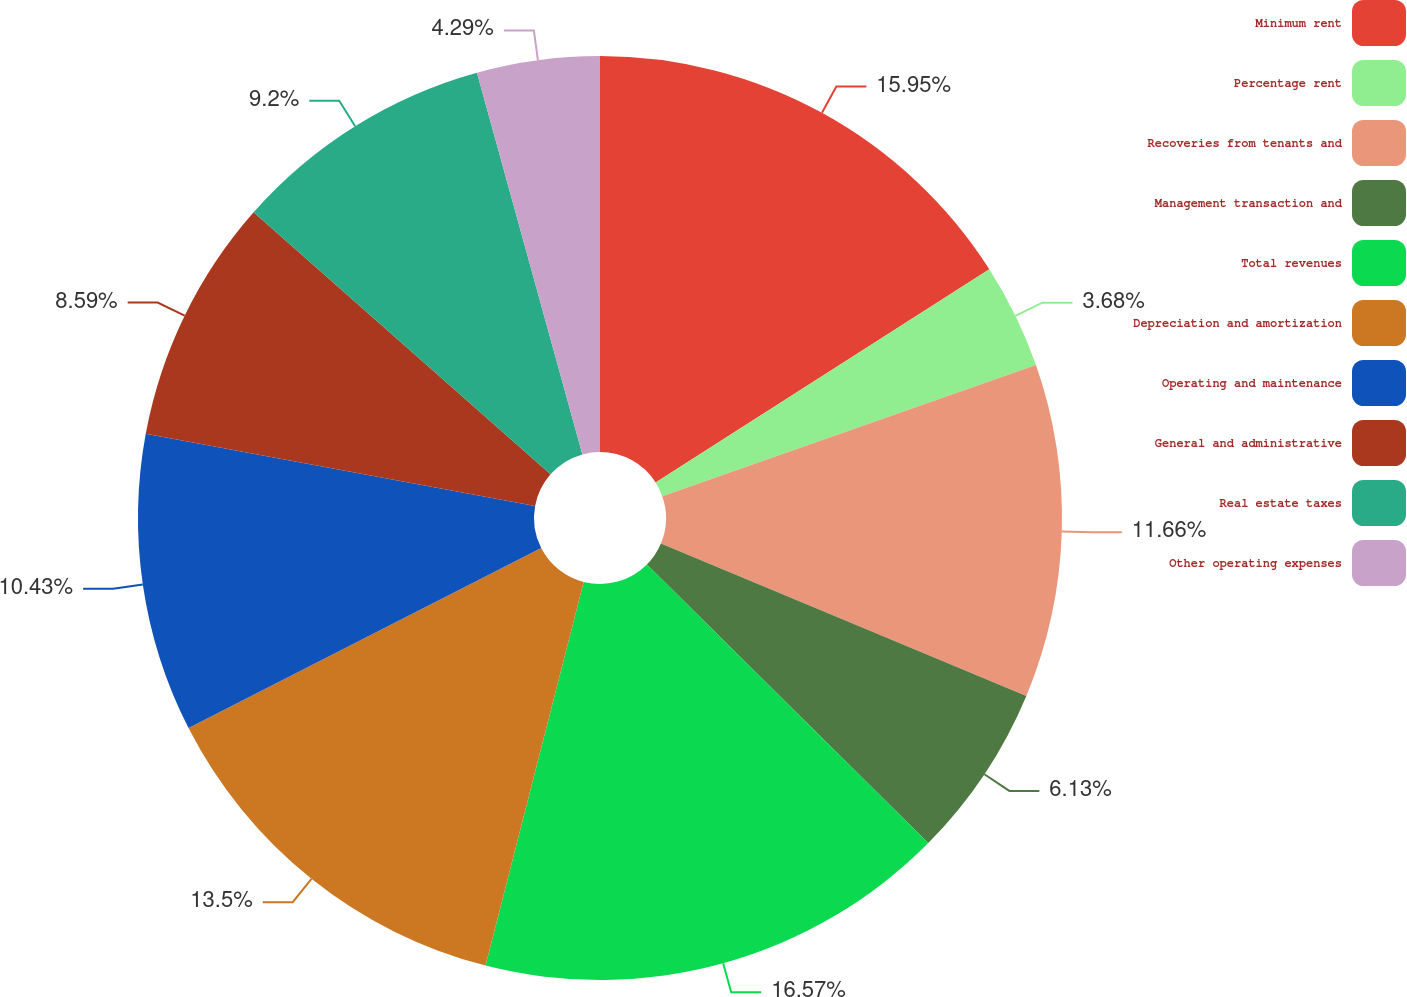Convert chart. <chart><loc_0><loc_0><loc_500><loc_500><pie_chart><fcel>Minimum rent<fcel>Percentage rent<fcel>Recoveries from tenants and<fcel>Management transaction and<fcel>Total revenues<fcel>Depreciation and amortization<fcel>Operating and maintenance<fcel>General and administrative<fcel>Real estate taxes<fcel>Other operating expenses<nl><fcel>15.95%<fcel>3.68%<fcel>11.66%<fcel>6.13%<fcel>16.56%<fcel>13.5%<fcel>10.43%<fcel>8.59%<fcel>9.2%<fcel>4.29%<nl></chart> 